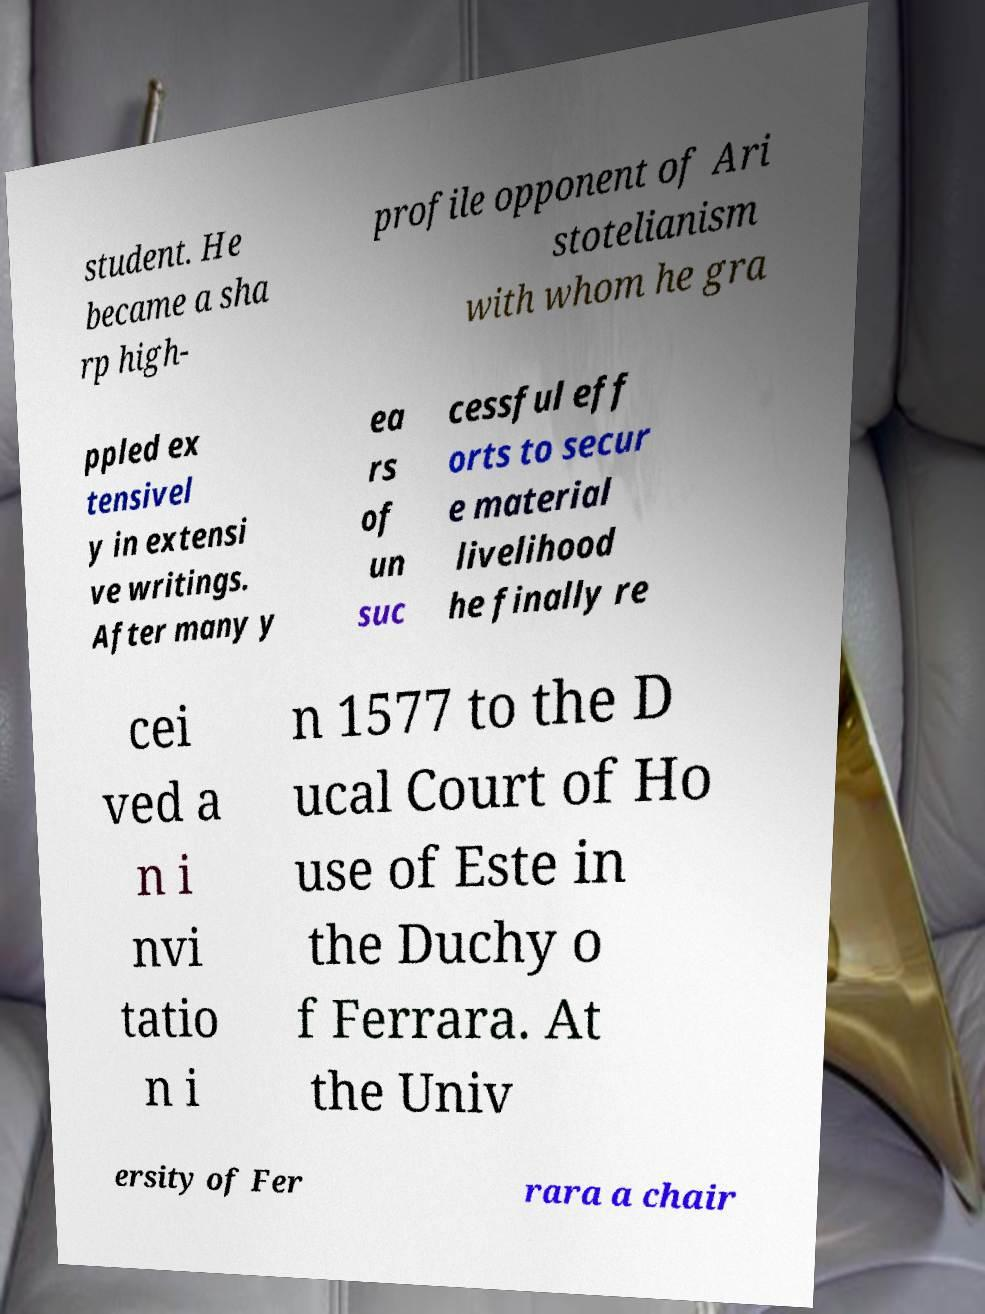Can you read and provide the text displayed in the image?This photo seems to have some interesting text. Can you extract and type it out for me? student. He became a sha rp high- profile opponent of Ari stotelianism with whom he gra ppled ex tensivel y in extensi ve writings. After many y ea rs of un suc cessful eff orts to secur e material livelihood he finally re cei ved a n i nvi tatio n i n 1577 to the D ucal Court of Ho use of Este in the Duchy o f Ferrara. At the Univ ersity of Fer rara a chair 